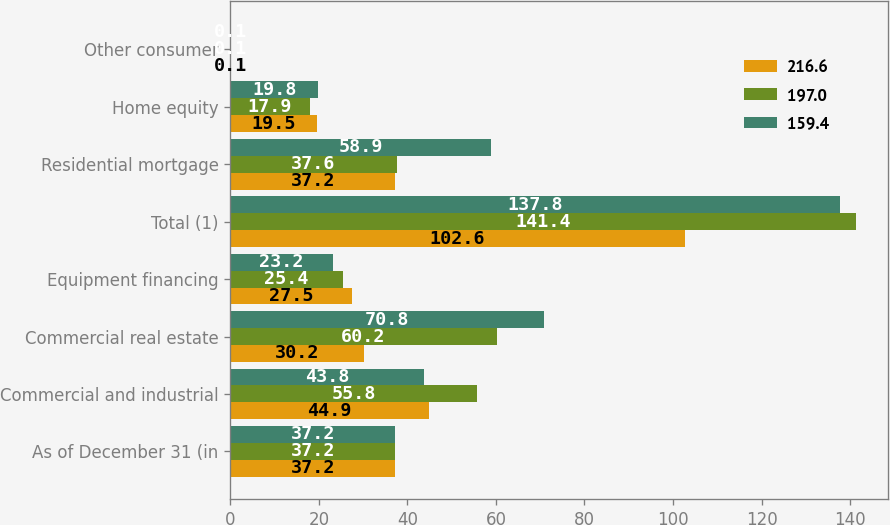Convert chart to OTSL. <chart><loc_0><loc_0><loc_500><loc_500><stacked_bar_chart><ecel><fcel>As of December 31 (in<fcel>Commercial and industrial<fcel>Commercial real estate<fcel>Equipment financing<fcel>Total (1)<fcel>Residential mortgage<fcel>Home equity<fcel>Other consumer<nl><fcel>216.6<fcel>37.2<fcel>44.9<fcel>30.2<fcel>27.5<fcel>102.6<fcel>37.2<fcel>19.5<fcel>0.1<nl><fcel>197<fcel>37.2<fcel>55.8<fcel>60.2<fcel>25.4<fcel>141.4<fcel>37.6<fcel>17.9<fcel>0.1<nl><fcel>159.4<fcel>37.2<fcel>43.8<fcel>70.8<fcel>23.2<fcel>137.8<fcel>58.9<fcel>19.8<fcel>0.1<nl></chart> 